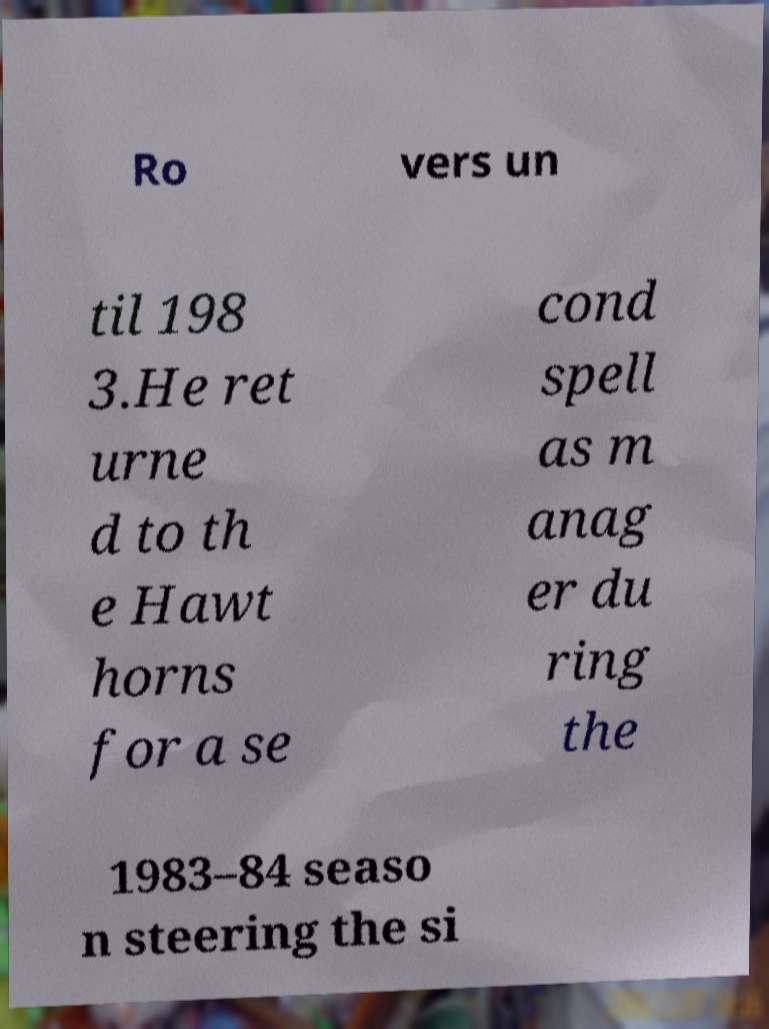Can you read and provide the text displayed in the image?This photo seems to have some interesting text. Can you extract and type it out for me? Ro vers un til 198 3.He ret urne d to th e Hawt horns for a se cond spell as m anag er du ring the 1983–84 seaso n steering the si 